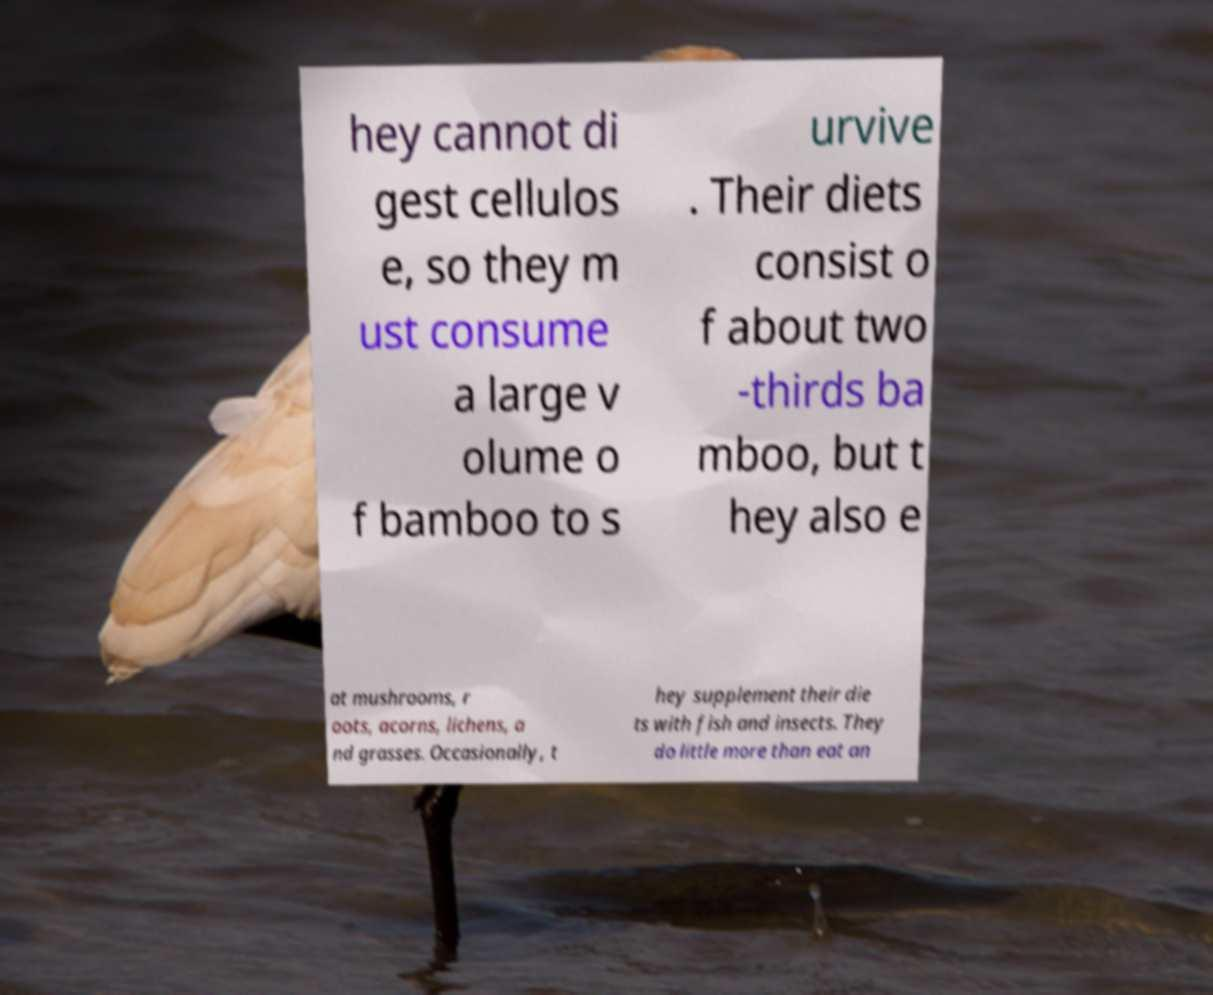Can you accurately transcribe the text from the provided image for me? hey cannot di gest cellulos e, so they m ust consume a large v olume o f bamboo to s urvive . Their diets consist o f about two -thirds ba mboo, but t hey also e at mushrooms, r oots, acorns, lichens, a nd grasses. Occasionally, t hey supplement their die ts with fish and insects. They do little more than eat an 